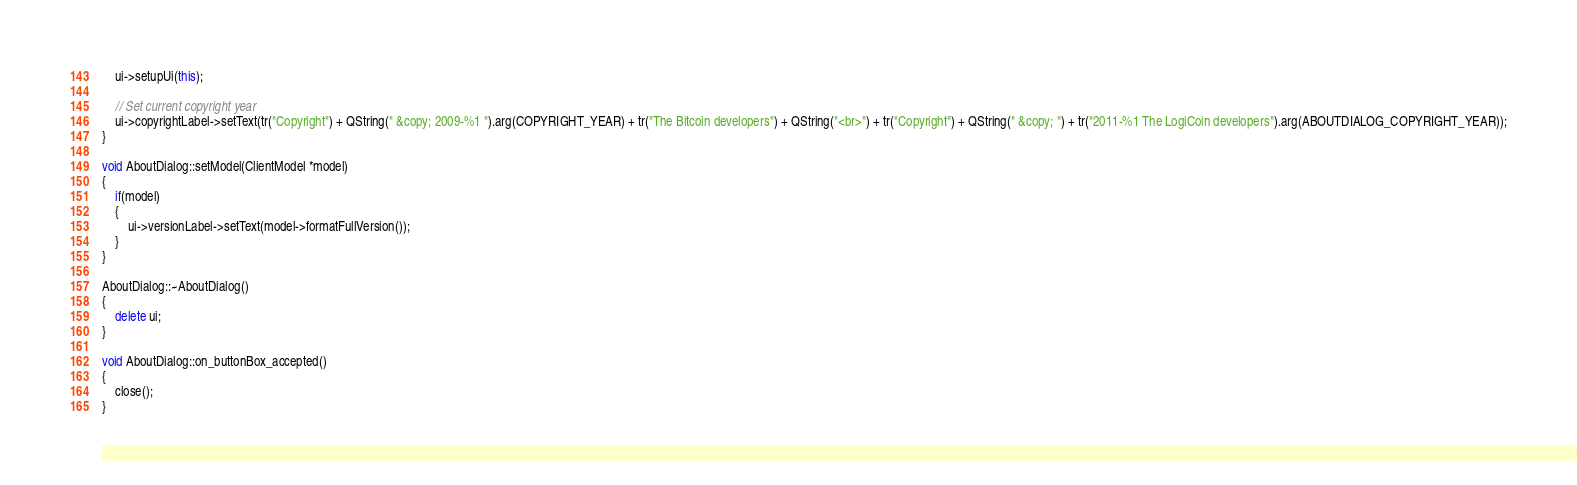Convert code to text. <code><loc_0><loc_0><loc_500><loc_500><_C++_>    ui->setupUi(this);

    // Set current copyright year
    ui->copyrightLabel->setText(tr("Copyright") + QString(" &copy; 2009-%1 ").arg(COPYRIGHT_YEAR) + tr("The Bitcoin developers") + QString("<br>") + tr("Copyright") + QString(" &copy; ") + tr("2011-%1 The LogiCoin developers").arg(ABOUTDIALOG_COPYRIGHT_YEAR));
}

void AboutDialog::setModel(ClientModel *model)
{
    if(model)
    {
        ui->versionLabel->setText(model->formatFullVersion());
    }
}

AboutDialog::~AboutDialog()
{
    delete ui;
}

void AboutDialog::on_buttonBox_accepted()
{
    close();
}
</code> 